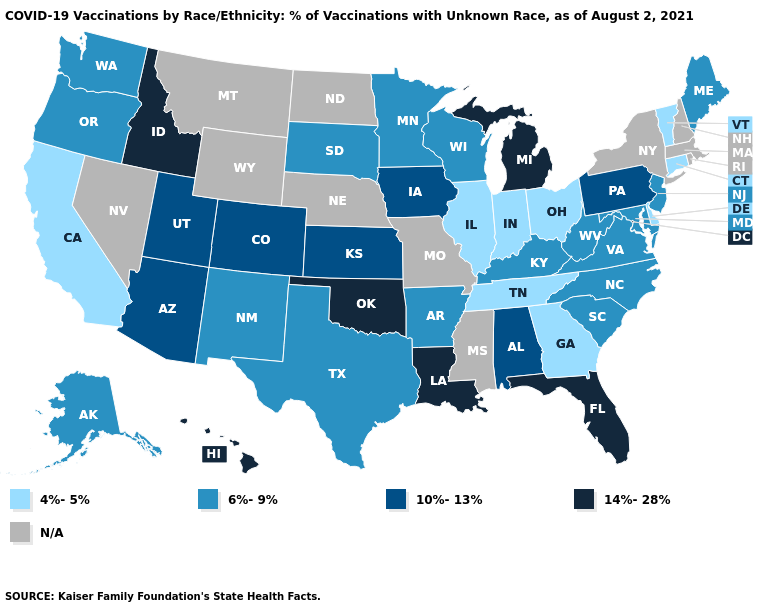What is the highest value in the Northeast ?
Short answer required. 10%-13%. Does the map have missing data?
Short answer required. Yes. Name the states that have a value in the range 6%-9%?
Keep it brief. Alaska, Arkansas, Kentucky, Maine, Maryland, Minnesota, New Jersey, New Mexico, North Carolina, Oregon, South Carolina, South Dakota, Texas, Virginia, Washington, West Virginia, Wisconsin. What is the value of Nevada?
Concise answer only. N/A. What is the lowest value in the Northeast?
Answer briefly. 4%-5%. What is the value of Ohio?
Answer briefly. 4%-5%. Name the states that have a value in the range N/A?
Quick response, please. Massachusetts, Mississippi, Missouri, Montana, Nebraska, Nevada, New Hampshire, New York, North Dakota, Rhode Island, Wyoming. Name the states that have a value in the range 6%-9%?
Short answer required. Alaska, Arkansas, Kentucky, Maine, Maryland, Minnesota, New Jersey, New Mexico, North Carolina, Oregon, South Carolina, South Dakota, Texas, Virginia, Washington, West Virginia, Wisconsin. What is the highest value in the MidWest ?
Answer briefly. 14%-28%. Name the states that have a value in the range 6%-9%?
Be succinct. Alaska, Arkansas, Kentucky, Maine, Maryland, Minnesota, New Jersey, New Mexico, North Carolina, Oregon, South Carolina, South Dakota, Texas, Virginia, Washington, West Virginia, Wisconsin. Does Connecticut have the lowest value in the USA?
Be succinct. Yes. Does Tennessee have the lowest value in the USA?
Give a very brief answer. Yes. What is the lowest value in the USA?
Quick response, please. 4%-5%. 